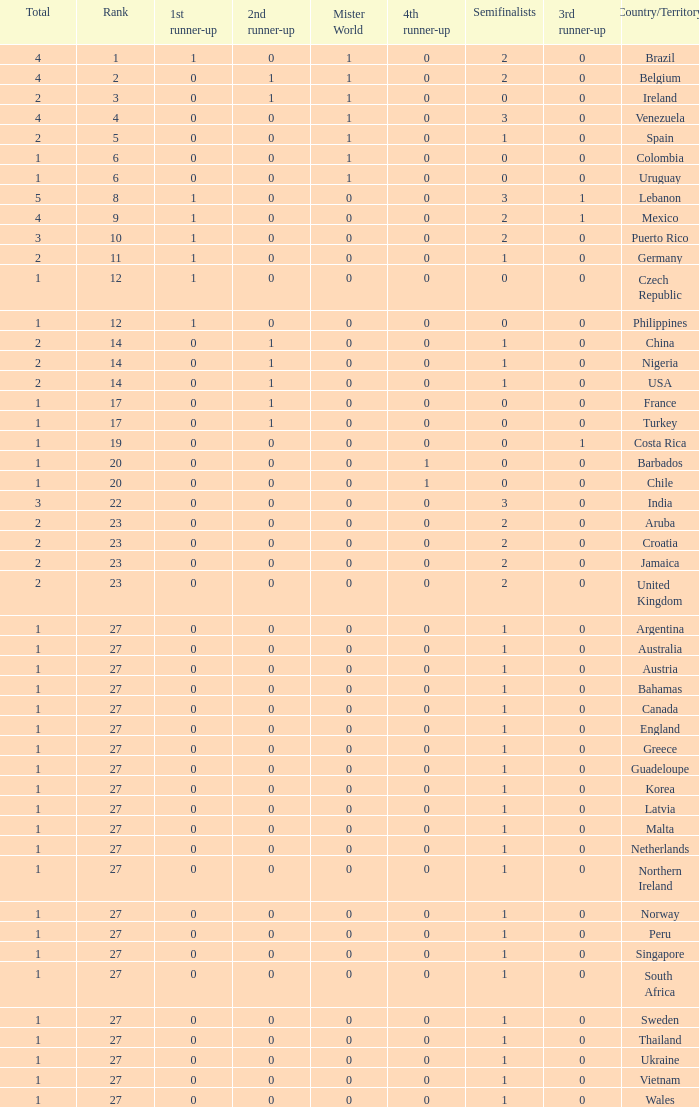What is the smallest 1st runner up value? 0.0. 